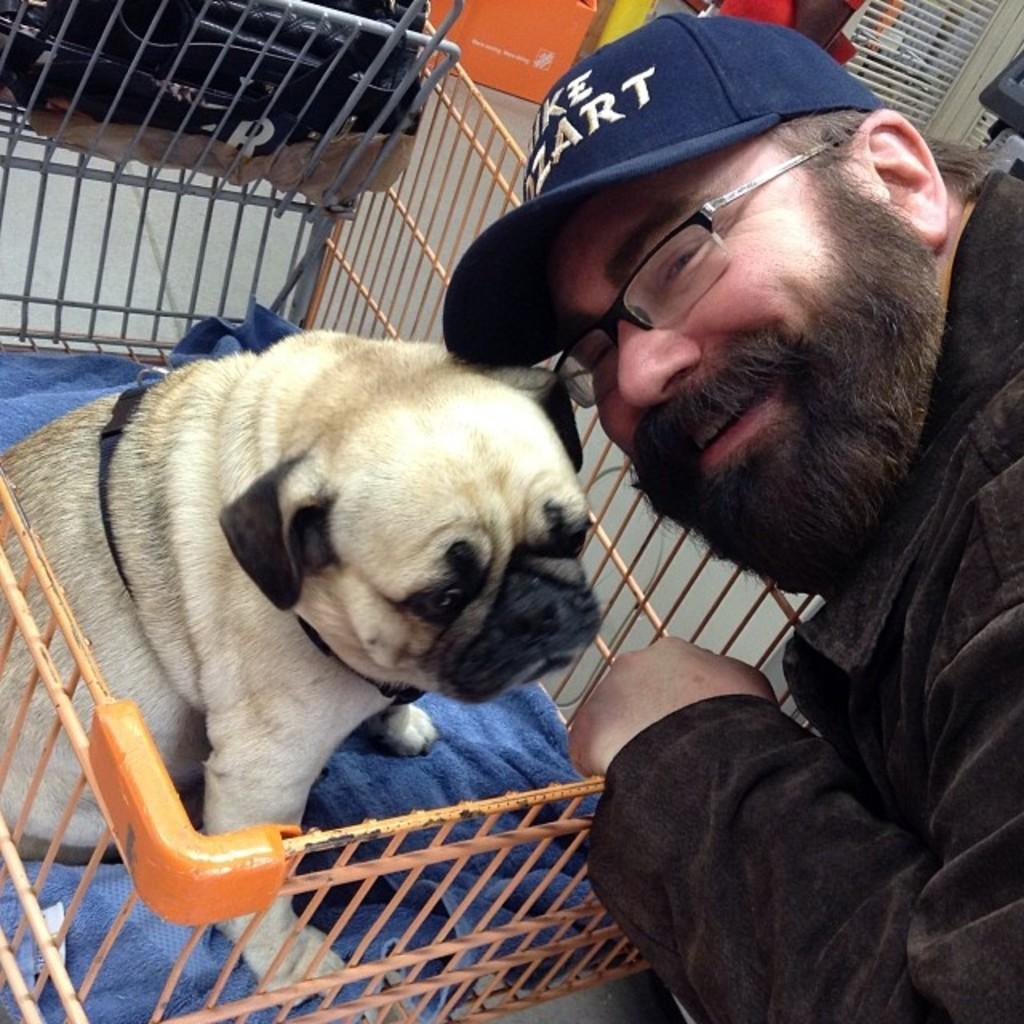Who or what is present in the image? There is a person and a dog in the image. Can you describe the dog's location in the image? The dog is in a basket in the image. What type of humor can be seen in the image? There is no humor present in the image; it simply shows a person and a dog with the dog in a basket. Can you describe the kettle in the image? There is no kettle present in the image. 